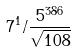Convert formula to latex. <formula><loc_0><loc_0><loc_500><loc_500>7 ^ { 1 } / \frac { 5 ^ { 3 8 6 } } { \sqrt { 1 0 8 } }</formula> 